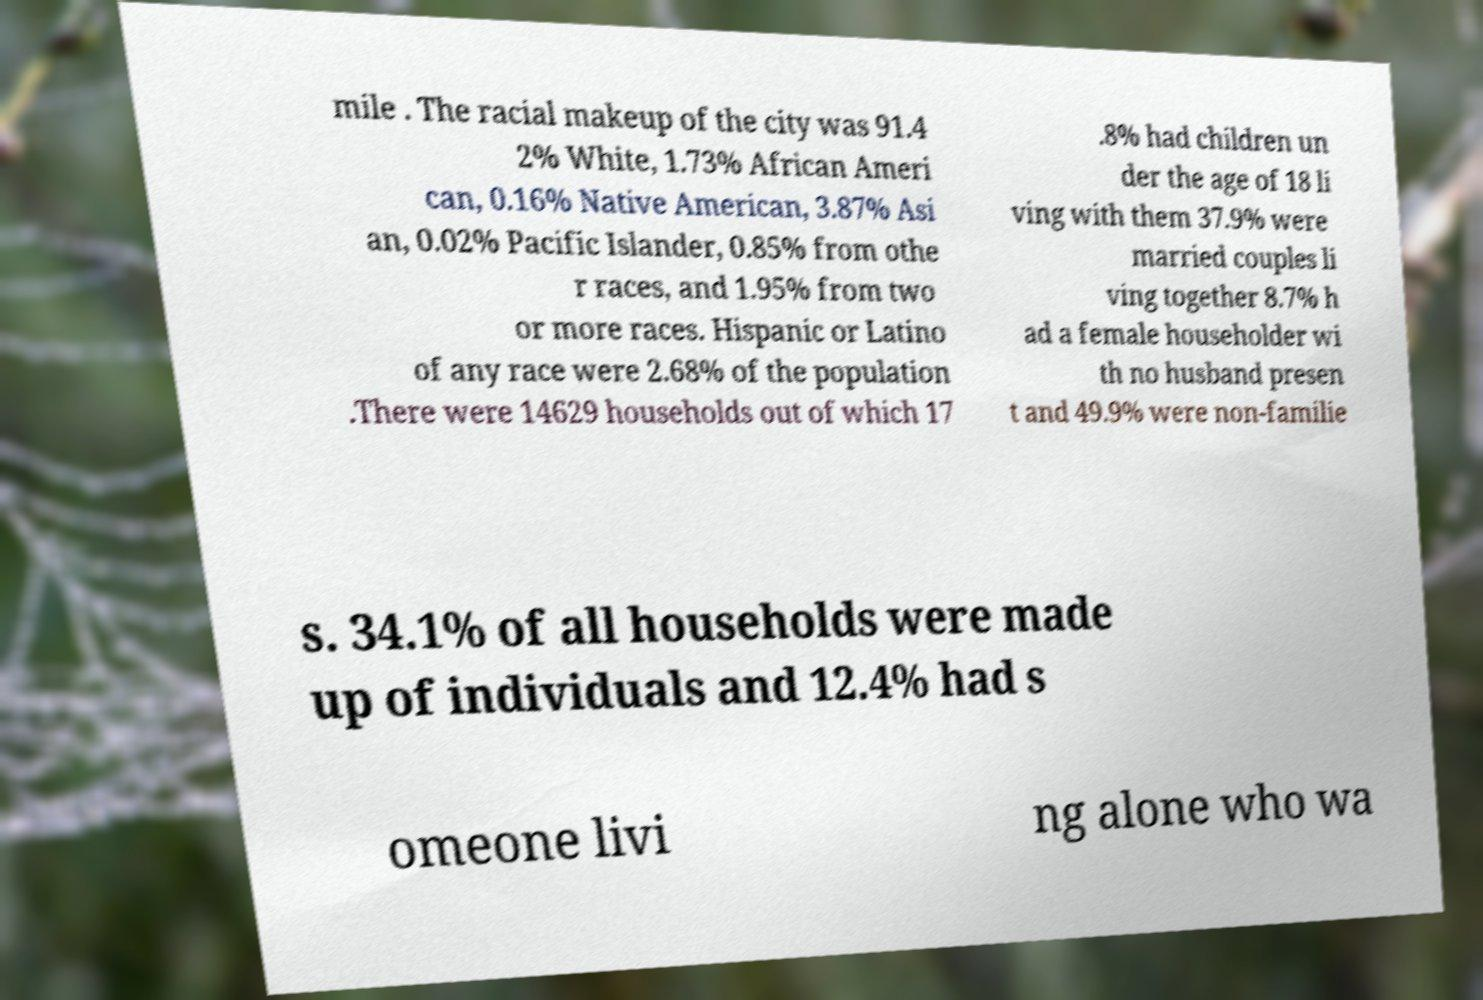Can you accurately transcribe the text from the provided image for me? mile . The racial makeup of the city was 91.4 2% White, 1.73% African Ameri can, 0.16% Native American, 3.87% Asi an, 0.02% Pacific Islander, 0.85% from othe r races, and 1.95% from two or more races. Hispanic or Latino of any race were 2.68% of the population .There were 14629 households out of which 17 .8% had children un der the age of 18 li ving with them 37.9% were married couples li ving together 8.7% h ad a female householder wi th no husband presen t and 49.9% were non-familie s. 34.1% of all households were made up of individuals and 12.4% had s omeone livi ng alone who wa 